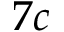Convert formula to latex. <formula><loc_0><loc_0><loc_500><loc_500>7 c</formula> 